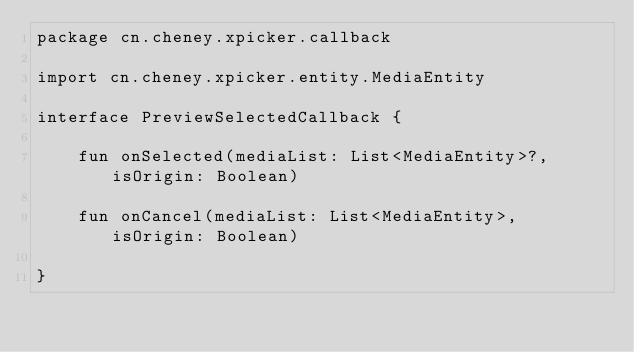<code> <loc_0><loc_0><loc_500><loc_500><_Kotlin_>package cn.cheney.xpicker.callback

import cn.cheney.xpicker.entity.MediaEntity

interface PreviewSelectedCallback {

    fun onSelected(mediaList: List<MediaEntity>?, isOrigin: Boolean)

    fun onCancel(mediaList: List<MediaEntity>, isOrigin: Boolean)

}</code> 